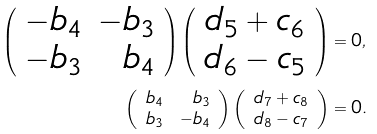<formula> <loc_0><loc_0><loc_500><loc_500>\left ( \begin{array} { r r } - b _ { 4 } & - b _ { 3 } \\ - b _ { 3 } & b _ { 4 } \end{array} \right ) \left ( \begin{array} { c } d _ { 5 } + c _ { 6 } \\ d _ { 6 } - c _ { 5 } \end{array} \right ) & = 0 , \\ \left ( \begin{array} { r r } b _ { 4 } & b _ { 3 } \\ b _ { 3 } & - b _ { 4 } \end{array} \right ) \left ( \begin{array} { c } d _ { 7 } + c _ { 8 } \\ d _ { 8 } - c _ { 7 } \end{array} \right ) & = 0 .</formula> 